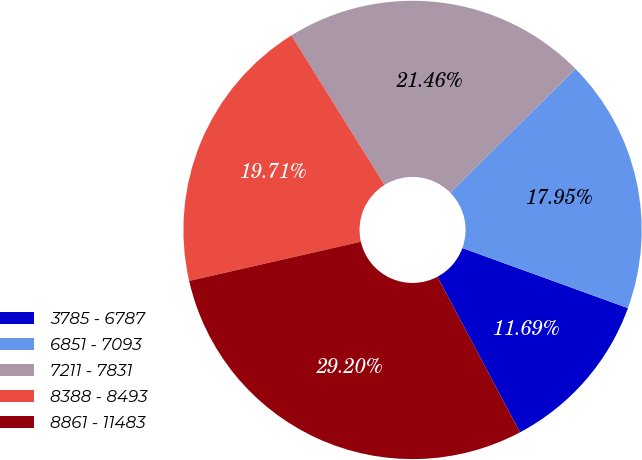Convert chart to OTSL. <chart><loc_0><loc_0><loc_500><loc_500><pie_chart><fcel>3785 - 6787<fcel>6851 - 7093<fcel>7211 - 7831<fcel>8388 - 8493<fcel>8861 - 11483<nl><fcel>11.69%<fcel>17.95%<fcel>21.46%<fcel>19.71%<fcel>29.2%<nl></chart> 